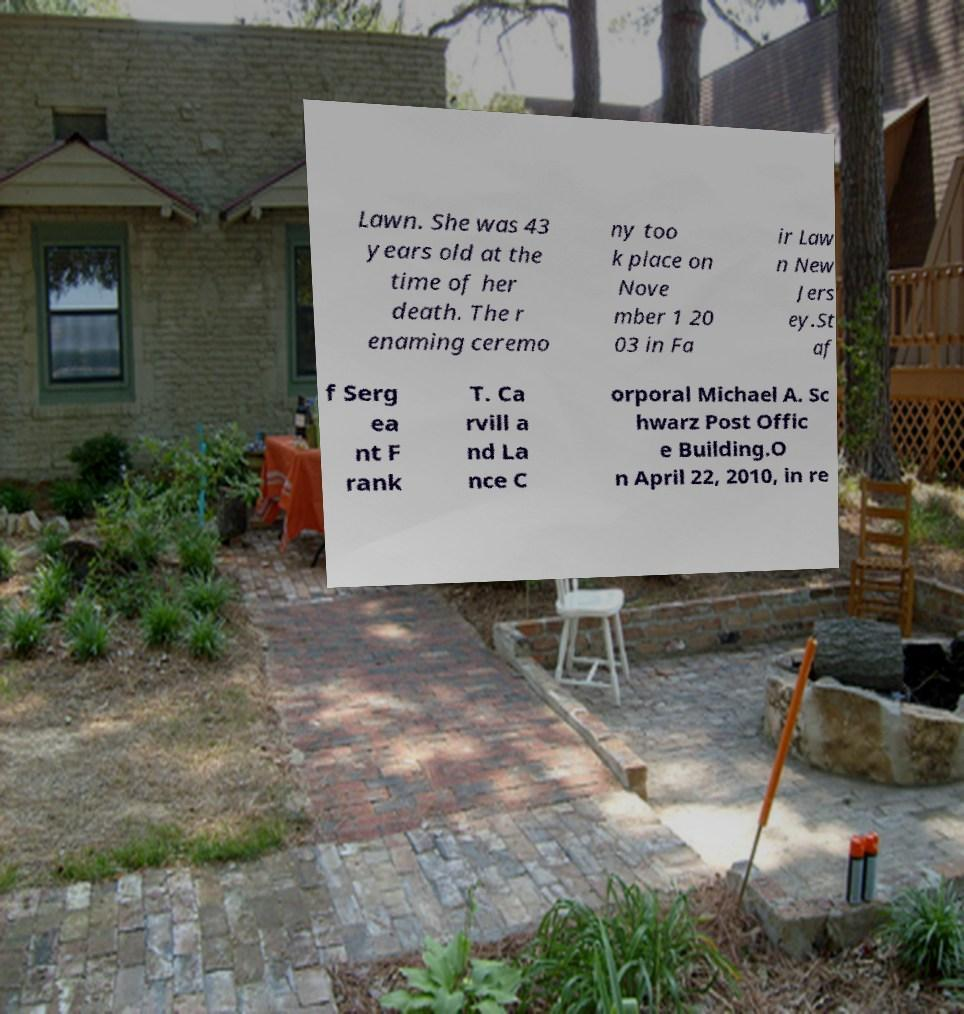Could you assist in decoding the text presented in this image and type it out clearly? Lawn. She was 43 years old at the time of her death. The r enaming ceremo ny too k place on Nove mber 1 20 03 in Fa ir Law n New Jers ey.St af f Serg ea nt F rank T. Ca rvill a nd La nce C orporal Michael A. Sc hwarz Post Offic e Building.O n April 22, 2010, in re 